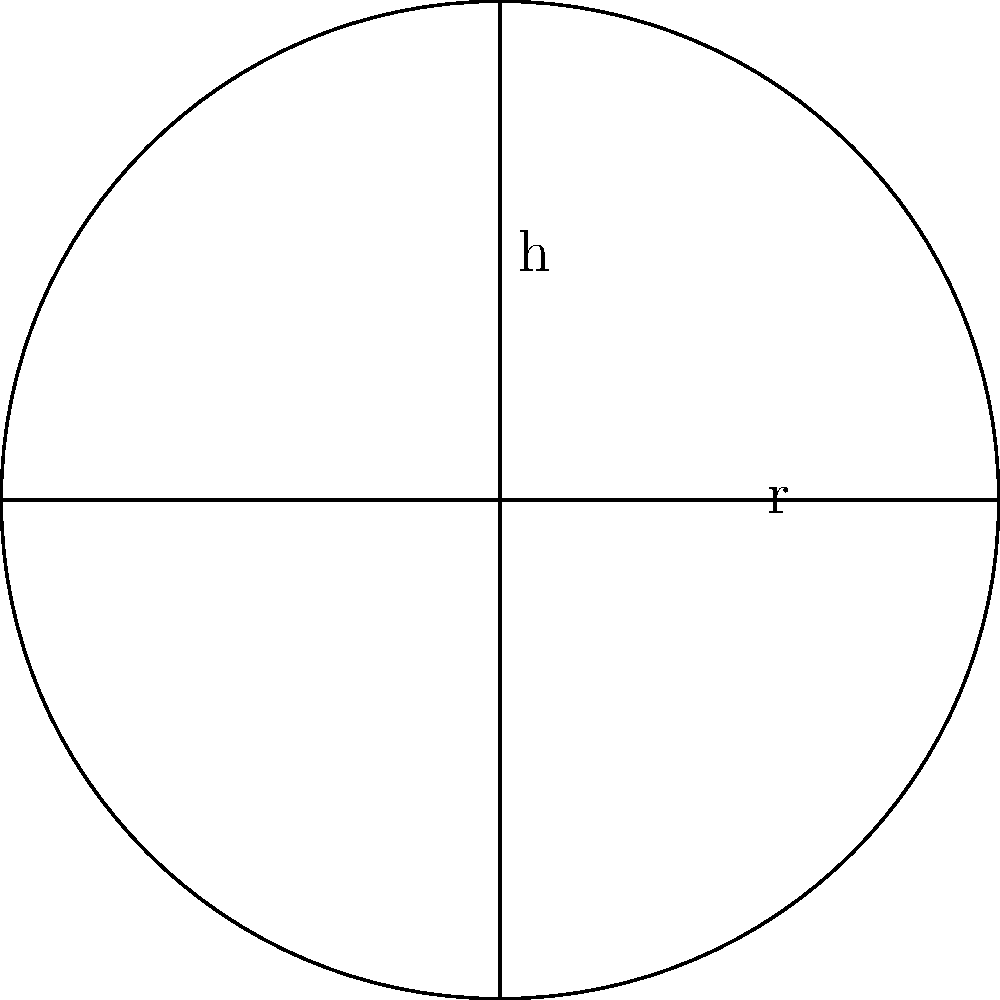As a busy mom, you're always on the go and need to stay hydrated. You bought a cylindrical water bottle for your daily errands. If the bottle has a radius of 4 cm and a height of 20 cm, what is its volume in milliliters? Let's approach this step-by-step:

1. Recall the formula for the volume of a cylinder:
   $V = \pi r^2 h$
   Where $V$ is volume, $r$ is radius, and $h$ is height.

2. We're given:
   Radius $(r) = 4$ cm
   Height $(h) = 20$ cm

3. Let's substitute these values into our formula:
   $V = \pi (4\text{ cm})^2 (20\text{ cm})$

4. Simplify:
   $V = \pi (16\text{ cm}^2) (20\text{ cm})$
   $V = 320\pi\text{ cm}^3$

5. Calculate (use 3.14159 for $\pi$):
   $V \approx 1005.31\text{ cm}^3$

6. Convert cubic centimeters to milliliters:
   1 cm³ = 1 mL, so our answer is already in milliliters.

Therefore, the volume of the water bottle is approximately 1005.31 mL.
Answer: 1005.31 mL 